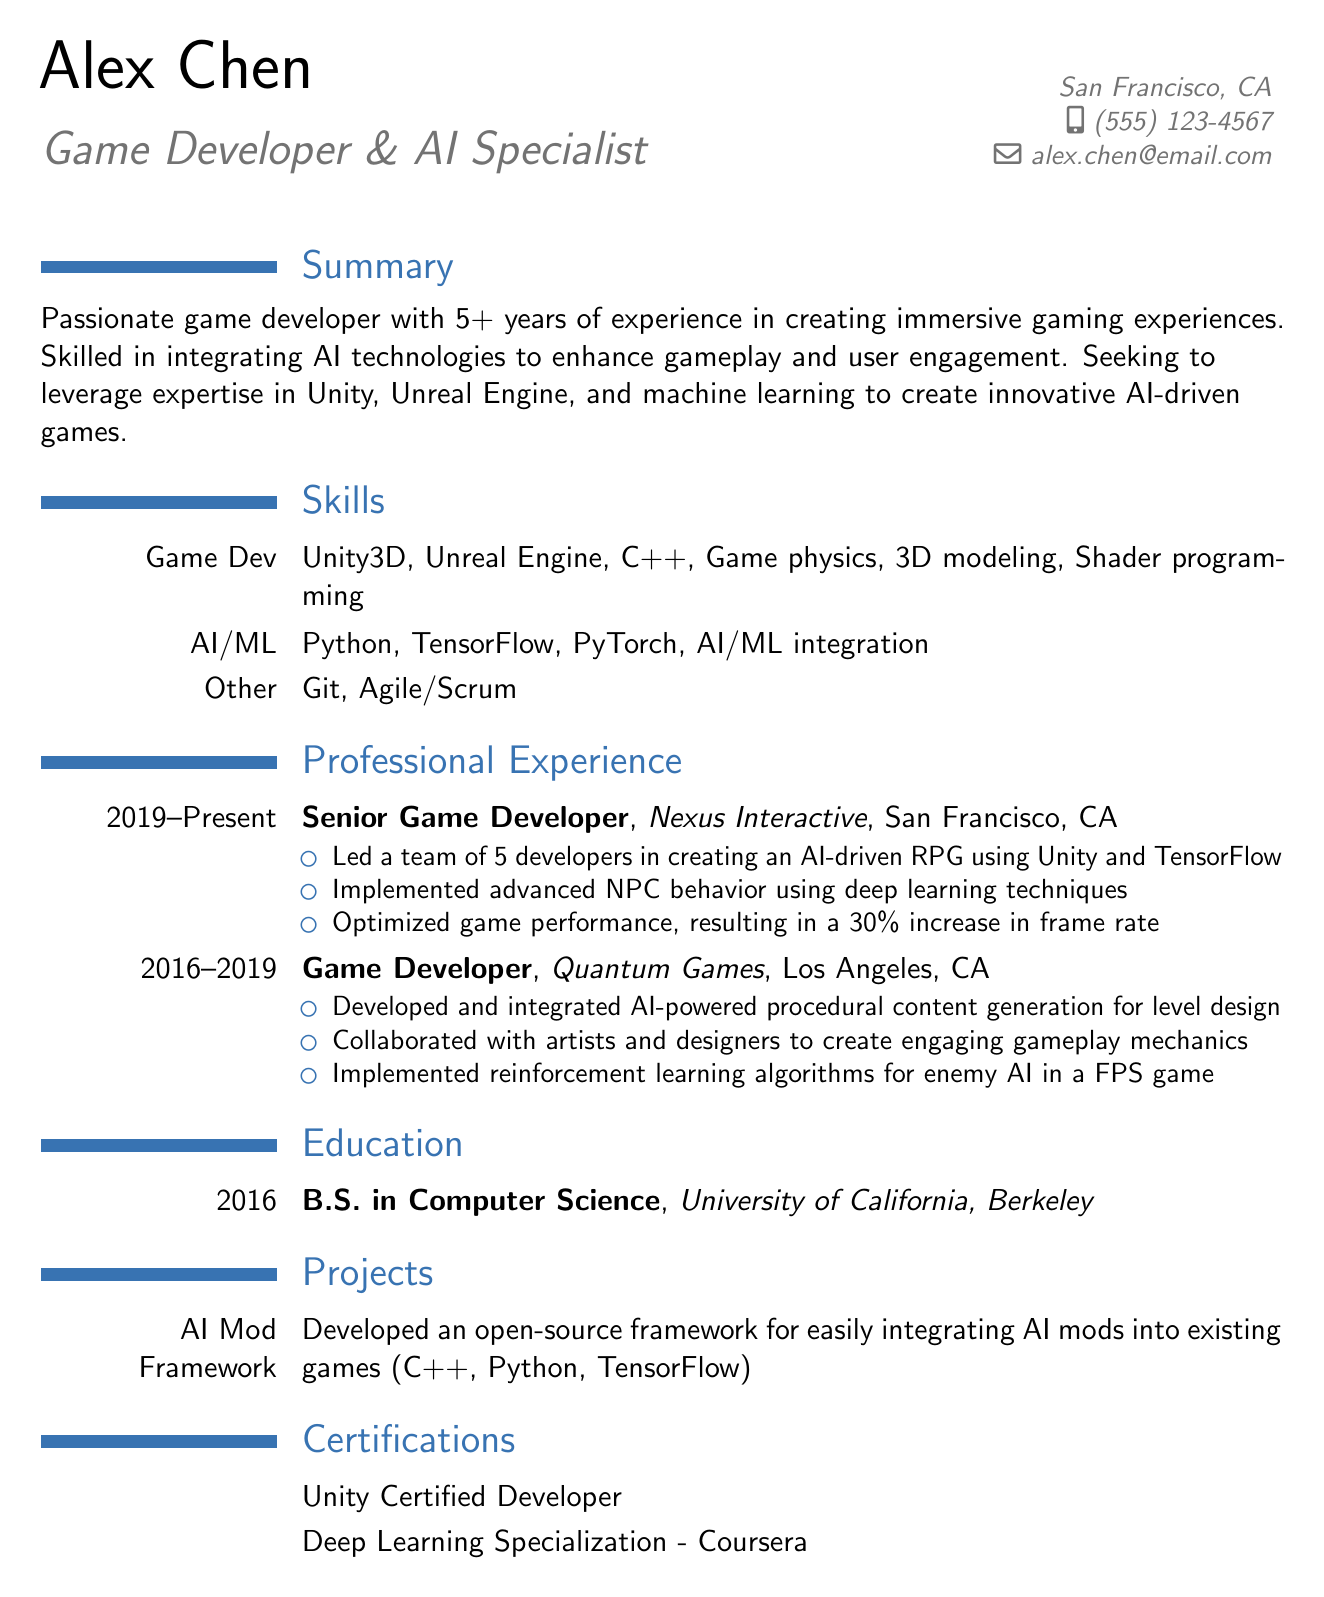What is the full name of the applicant? The full name of the applicant is provided in the personal information section of the document.
Answer: Alex Chen How many years of experience does Alex have in game development? The summary section states the total years of experience in game development.
Answer: 5+ What is the degree obtained by Alex? The education section lists the degree obtained by Alex.
Answer: B.S. in Computer Science Which company did Alex work for as a Senior Game Developer? The professional experience section specifies the company where Alex held the position of Senior Game Developer.
Answer: Nexus Interactive In which city is Nexus Interactive located? The professional experience section indicates the location of Nexus Interactive.
Answer: San Francisco, CA What technology was used to develop the AI-driven RPG? The responsibilities under the Senior Game Developer position mention the technology used for development.
Answer: Unity and TensorFlow What project did Alex develop related to AI mods? The projects section describes the project Alex worked on regarding AI mods.
Answer: AI Mod Framework How many developers did Alex lead in their current role? The responsibilities listed under the Senior Game Developer position mention the team size Alex led.
Answer: 5 developers What certification has Alex obtained related to Unity? The certifications section lists the specific certification related to Unity.
Answer: Unity Certified Developer 